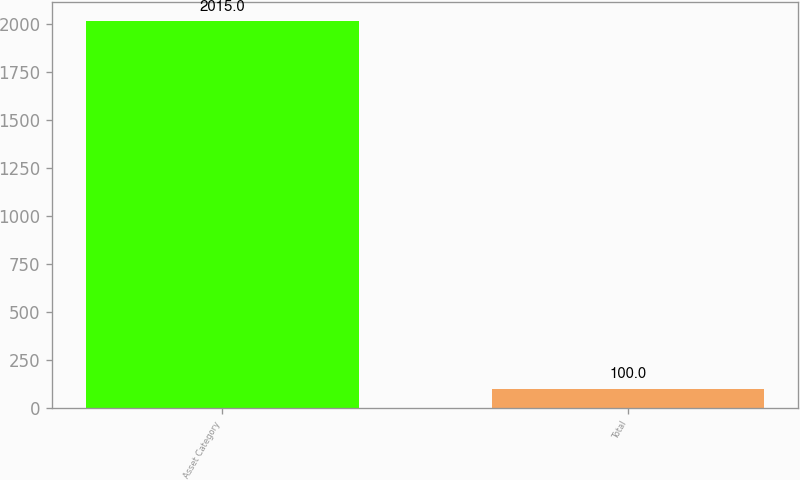<chart> <loc_0><loc_0><loc_500><loc_500><bar_chart><fcel>Asset Category<fcel>Total<nl><fcel>2015<fcel>100<nl></chart> 